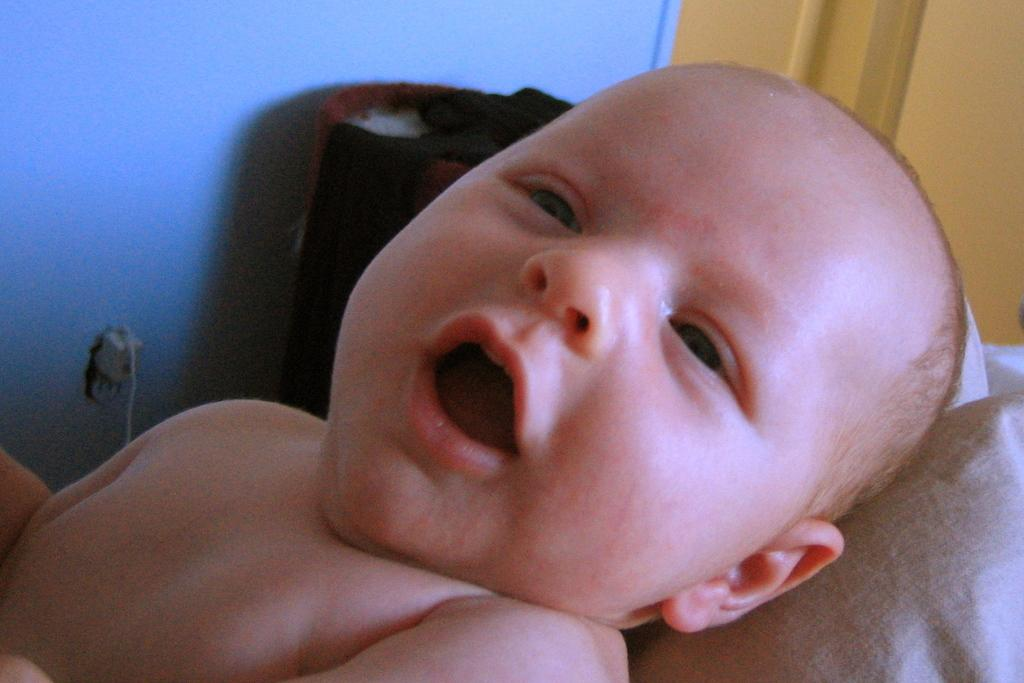Where was the image taken? The image was taken indoors. What can be seen in the background of the image? There is a wall with a door in the background. What is the main subject of the image? There is an infant in the middle of the image. What is located at the bottom of the image? There is a pillow at the bottom of the image. What type of paste is being used by the infant in the image? There is no paste present in the image; it features an infant and a pillow indoors. 